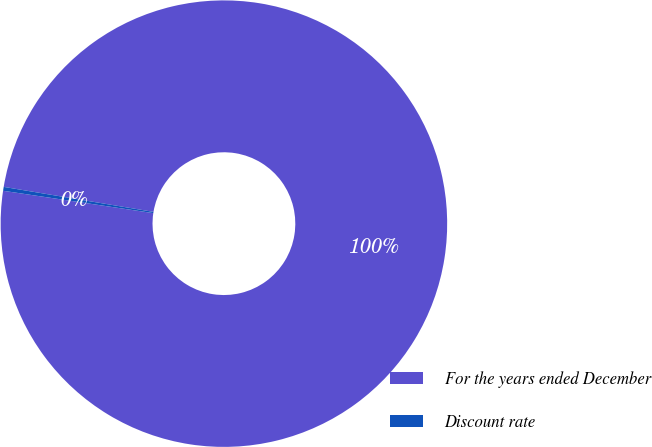<chart> <loc_0><loc_0><loc_500><loc_500><pie_chart><fcel>For the years ended December<fcel>Discount rate<nl><fcel>99.72%<fcel>0.28%<nl></chart> 